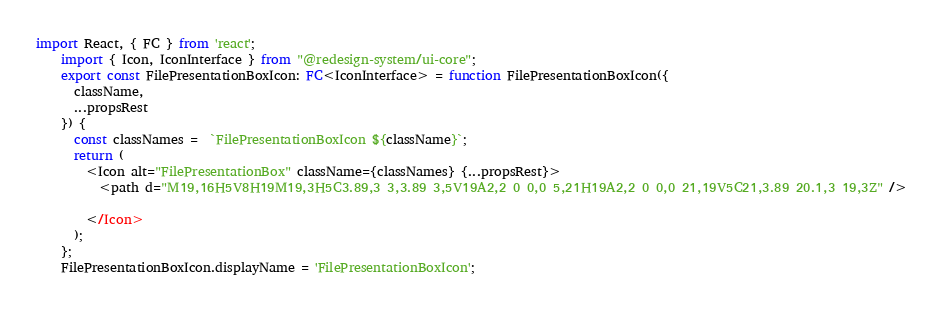Convert code to text. <code><loc_0><loc_0><loc_500><loc_500><_TypeScript_>import React, { FC } from 'react';
    import { Icon, IconInterface } from "@redesign-system/ui-core";
    export const FilePresentationBoxIcon: FC<IconInterface> = function FilePresentationBoxIcon({
      className,
      ...propsRest
    }) {
      const classNames =  `FilePresentationBoxIcon ${className}`;
      return (
        <Icon alt="FilePresentationBox" className={classNames} {...propsRest}>
          <path d="M19,16H5V8H19M19,3H5C3.89,3 3,3.89 3,5V19A2,2 0 0,0 5,21H19A2,2 0 0,0 21,19V5C21,3.89 20.1,3 19,3Z" />

        </Icon>
      );
    };
    FilePresentationBoxIcon.displayName = 'FilePresentationBoxIcon';
      </code> 